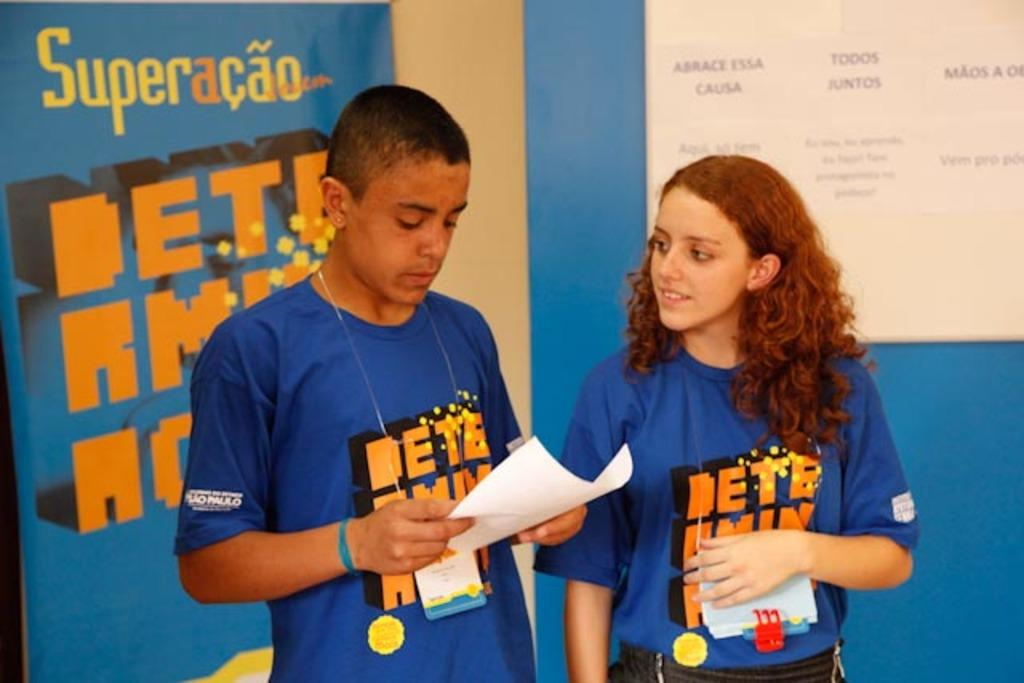How many people are present in the image? There are two persons in the image. What object can be seen in the image besides the people? There is a paper in the image. What can be seen in the background of the image? There is a banner in the background of the image. What type of bread is being served on the table in the image? There is no table or bread present in the image. What is the plot of the story being told in the image? The image does not depict a story or plot; it simply shows two persons and a paper. 